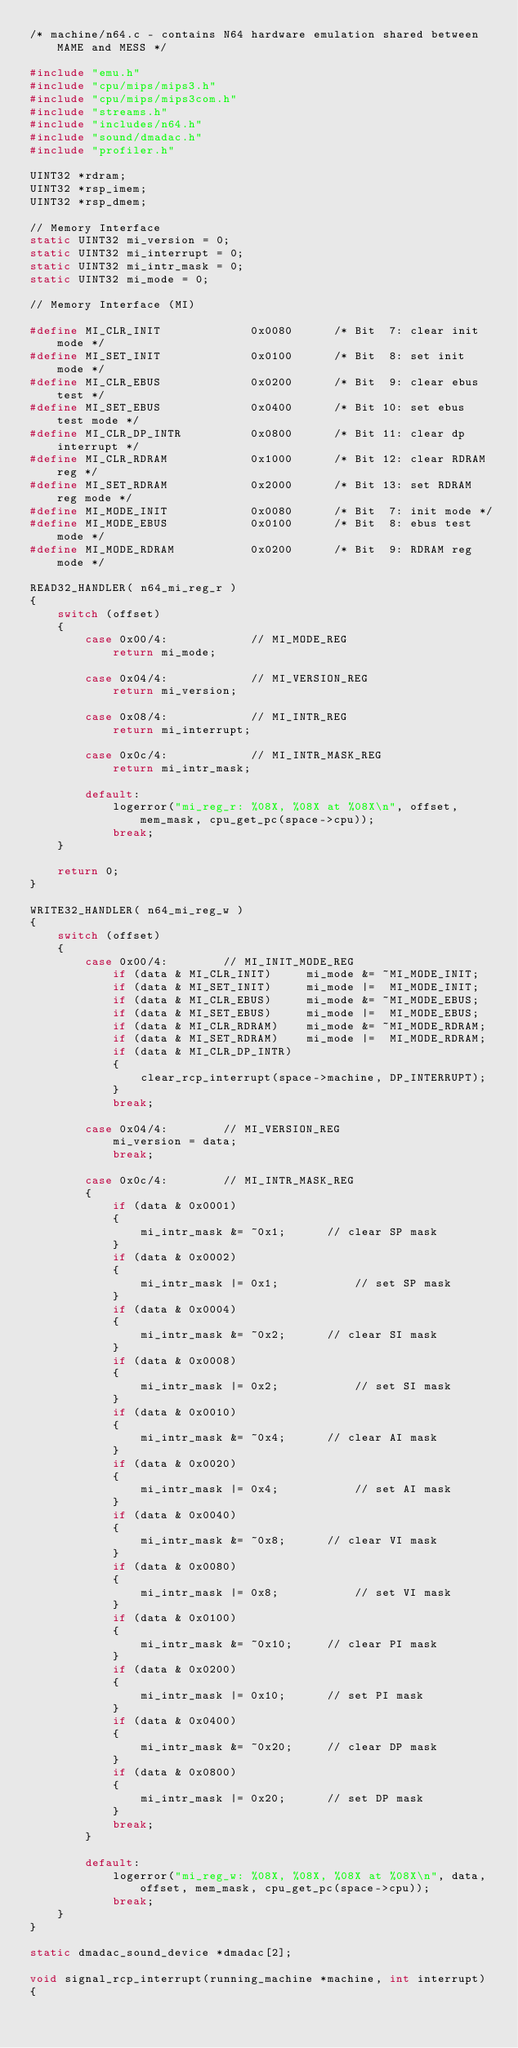Convert code to text. <code><loc_0><loc_0><loc_500><loc_500><_C_>/* machine/n64.c - contains N64 hardware emulation shared between MAME and MESS */

#include "emu.h"
#include "cpu/mips/mips3.h"
#include "cpu/mips/mips3com.h"
#include "streams.h"
#include "includes/n64.h"
#include "sound/dmadac.h"
#include "profiler.h"

UINT32 *rdram;
UINT32 *rsp_imem;
UINT32 *rsp_dmem;

// Memory Interface
static UINT32 mi_version = 0;
static UINT32 mi_interrupt = 0;
static UINT32 mi_intr_mask = 0;
static UINT32 mi_mode = 0;

// Memory Interface (MI)

#define MI_CLR_INIT             0x0080      /* Bit  7: clear init mode */
#define MI_SET_INIT             0x0100      /* Bit  8: set init mode */
#define MI_CLR_EBUS             0x0200      /* Bit  9: clear ebus test */
#define MI_SET_EBUS             0x0400      /* Bit 10: set ebus test mode */
#define MI_CLR_DP_INTR          0x0800      /* Bit 11: clear dp interrupt */
#define MI_CLR_RDRAM            0x1000      /* Bit 12: clear RDRAM reg */
#define MI_SET_RDRAM            0x2000      /* Bit 13: set RDRAM reg mode */
#define MI_MODE_INIT            0x0080      /* Bit  7: init mode */
#define MI_MODE_EBUS            0x0100      /* Bit  8: ebus test mode */
#define MI_MODE_RDRAM           0x0200      /* Bit  9: RDRAM reg mode */

READ32_HANDLER( n64_mi_reg_r )
{
	switch (offset)
	{
        case 0x00/4:            // MI_MODE_REG
            return mi_mode;

		case 0x04/4:			// MI_VERSION_REG
			return mi_version;

		case 0x08/4:			// MI_INTR_REG
			return mi_interrupt;

		case 0x0c/4:			// MI_INTR_MASK_REG
			return mi_intr_mask;

		default:
			logerror("mi_reg_r: %08X, %08X at %08X\n", offset, mem_mask, cpu_get_pc(space->cpu));
			break;
	}

	return 0;
}

WRITE32_HANDLER( n64_mi_reg_w )
{
	switch (offset)
	{
		case 0x00/4:		// MI_INIT_MODE_REG
            if (data & MI_CLR_INIT)     mi_mode &= ~MI_MODE_INIT;
            if (data & MI_SET_INIT)     mi_mode |=  MI_MODE_INIT;
            if (data & MI_CLR_EBUS)     mi_mode &= ~MI_MODE_EBUS;
            if (data & MI_SET_EBUS)     mi_mode |=  MI_MODE_EBUS;
            if (data & MI_CLR_RDRAM)    mi_mode &= ~MI_MODE_RDRAM;
            if (data & MI_SET_RDRAM)    mi_mode |=  MI_MODE_RDRAM;
            if (data & MI_CLR_DP_INTR)
			{
				clear_rcp_interrupt(space->machine, DP_INTERRUPT);
			}
			break;

		case 0x04/4:		// MI_VERSION_REG
			mi_version = data;
			break;

		case 0x0c/4:		// MI_INTR_MASK_REG
		{
            if (data & 0x0001)
            {
                mi_intr_mask &= ~0x1;      // clear SP mask
            }
            if (data & 0x0002)
            {
                mi_intr_mask |= 0x1;           // set SP mask
            }
            if (data & 0x0004)
            {
                mi_intr_mask &= ~0x2;      // clear SI mask
            }
            if (data & 0x0008)
            {
                mi_intr_mask |= 0x2;           // set SI mask
            }
            if (data & 0x0010)
            {
                mi_intr_mask &= ~0x4;      // clear AI mask
            }
            if (data & 0x0020)
            {
                mi_intr_mask |= 0x4;           // set AI mask
            }
            if (data & 0x0040)
            {
                mi_intr_mask &= ~0x8;      // clear VI mask
            }
            if (data & 0x0080)
            {
                mi_intr_mask |= 0x8;           // set VI mask
            }
            if (data & 0x0100)
            {
                mi_intr_mask &= ~0x10;     // clear PI mask
            }
            if (data & 0x0200)
            {
                mi_intr_mask |= 0x10;      // set PI mask
            }
            if (data & 0x0400)
            {
                mi_intr_mask &= ~0x20;     // clear DP mask
            }
            if (data & 0x0800)
            {
                mi_intr_mask |= 0x20;      // set DP mask
            }
			break;
		}

		default:
			logerror("mi_reg_w: %08X, %08X, %08X at %08X\n", data, offset, mem_mask, cpu_get_pc(space->cpu));
			break;
	}
}

static dmadac_sound_device *dmadac[2];

void signal_rcp_interrupt(running_machine *machine, int interrupt)
{</code> 